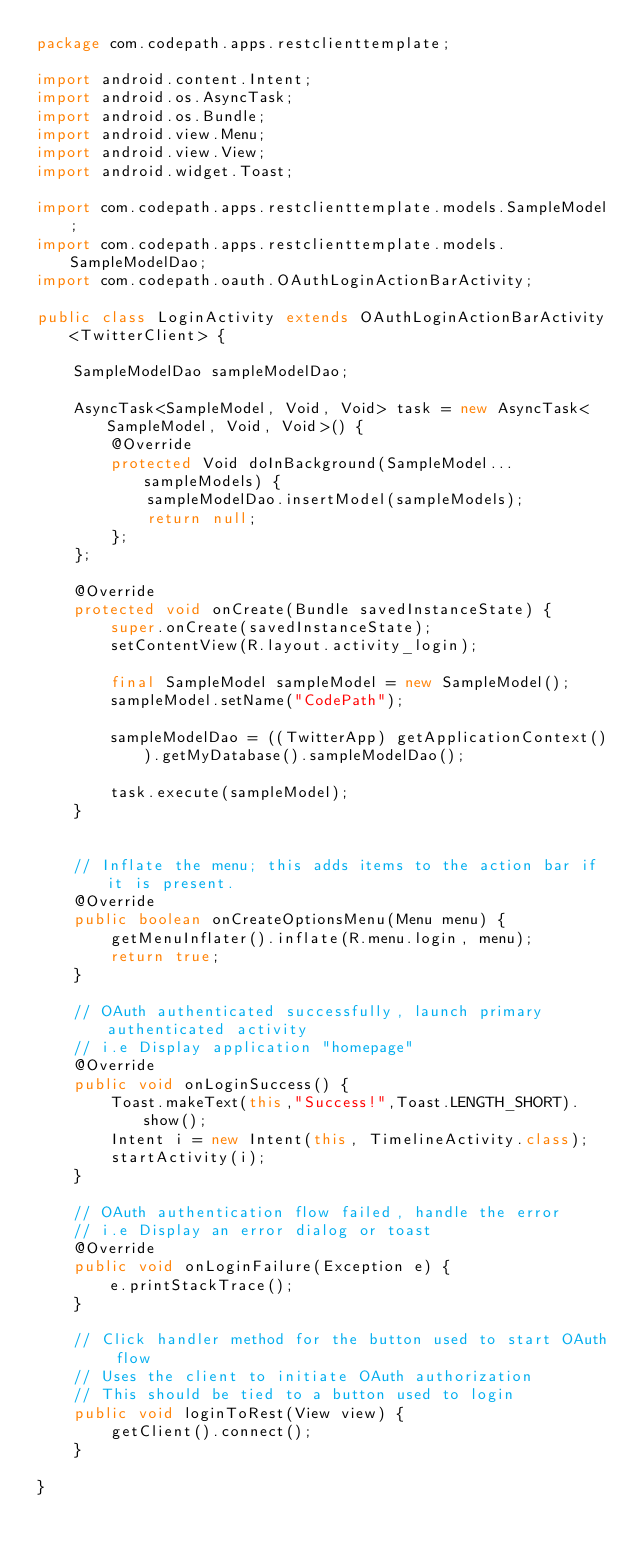<code> <loc_0><loc_0><loc_500><loc_500><_Java_>package com.codepath.apps.restclienttemplate;

import android.content.Intent;
import android.os.AsyncTask;
import android.os.Bundle;
import android.view.Menu;
import android.view.View;
import android.widget.Toast;

import com.codepath.apps.restclienttemplate.models.SampleModel;
import com.codepath.apps.restclienttemplate.models.SampleModelDao;
import com.codepath.oauth.OAuthLoginActionBarActivity;

public class LoginActivity extends OAuthLoginActionBarActivity<TwitterClient> {

	SampleModelDao sampleModelDao;

	AsyncTask<SampleModel, Void, Void> task = new AsyncTask<SampleModel, Void, Void>() {
		@Override
		protected Void doInBackground(SampleModel... sampleModels) {
			sampleModelDao.insertModel(sampleModels);
			return null;
		};
	};

	@Override
	protected void onCreate(Bundle savedInstanceState) {
		super.onCreate(savedInstanceState);
		setContentView(R.layout.activity_login);

		final SampleModel sampleModel = new SampleModel();
		sampleModel.setName("CodePath");

		sampleModelDao = ((TwitterApp) getApplicationContext()).getMyDatabase().sampleModelDao();

		task.execute(sampleModel);
	}


	// Inflate the menu; this adds items to the action bar if it is present.
	@Override
	public boolean onCreateOptionsMenu(Menu menu) {
		getMenuInflater().inflate(R.menu.login, menu);
		return true;
	}

	// OAuth authenticated successfully, launch primary authenticated activity
	// i.e Display application "homepage"
	@Override
	public void onLoginSuccess() {
		Toast.makeText(this,"Success!",Toast.LENGTH_SHORT).show();
		Intent i = new Intent(this, TimelineActivity.class);
		startActivity(i);
	}

	// OAuth authentication flow failed, handle the error
	// i.e Display an error dialog or toast
	@Override
	public void onLoginFailure(Exception e) {
		e.printStackTrace();
	}

	// Click handler method for the button used to start OAuth flow
	// Uses the client to initiate OAuth authorization
	// This should be tied to a button used to login
	public void loginToRest(View view) {
		getClient().connect();
	}

}
</code> 